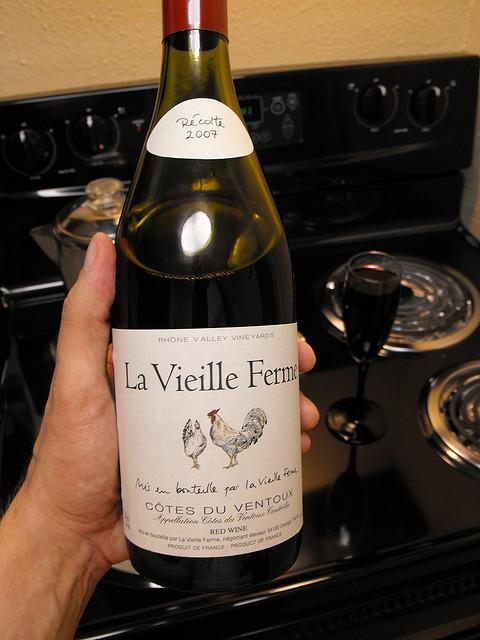What gift would this person enjoy assuming they like what they are holding?

Choices:
A) tennis ball
B) teddy bear
C) baseball bat
D) wine rack wine rack 